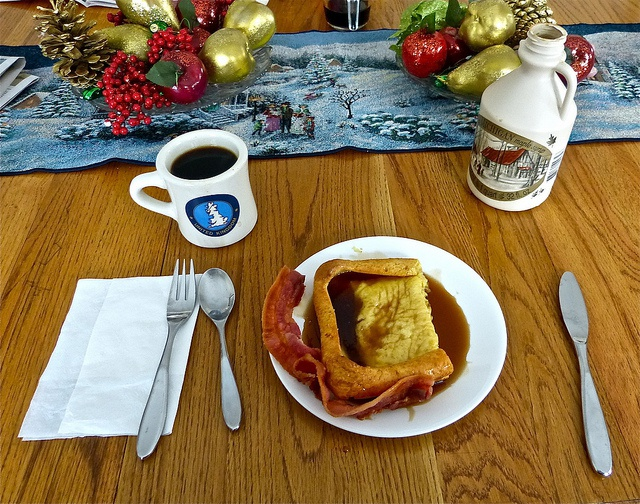Describe the objects in this image and their specific colors. I can see dining table in olive, lightgray, white, and maroon tones, bottle in white, darkgray, and gray tones, cup in white, lightgray, black, navy, and darkgray tones, knife in white, darkgray, lightblue, and maroon tones, and fork in white, darkgray, lightblue, and lightgray tones in this image. 